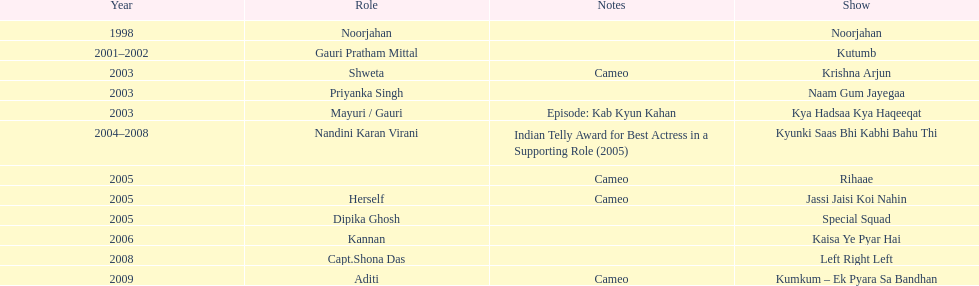In total, how many different tv series has gauri tejwani either starred or cameoed in? 11. 